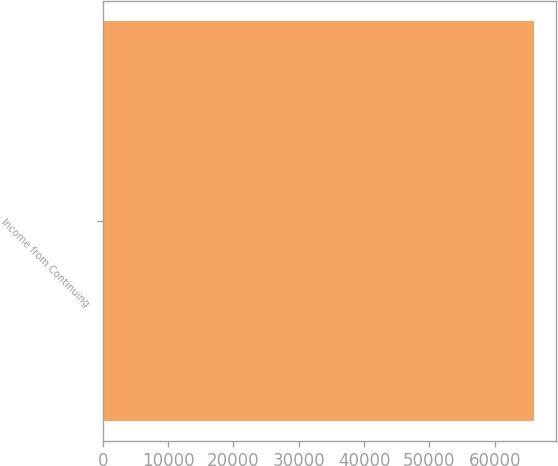Convert chart. <chart><loc_0><loc_0><loc_500><loc_500><bar_chart><fcel>Income from Continuing<nl><fcel>66016<nl></chart> 